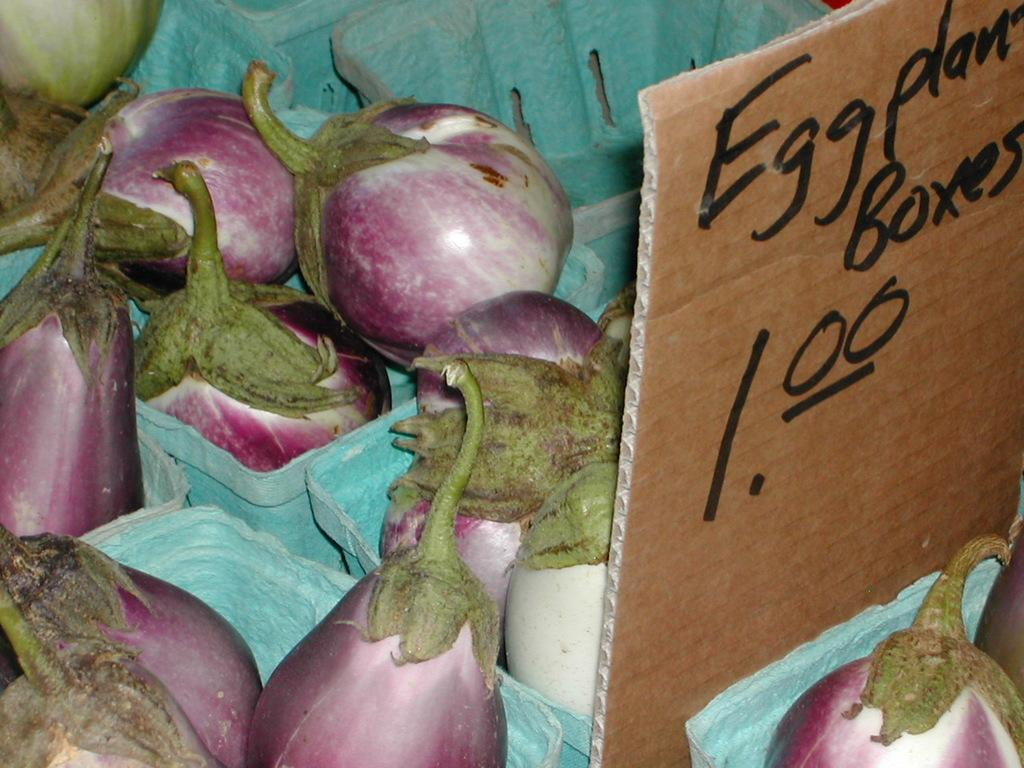What type of vegetable is present in the image? There are eggplants in the image. How are the eggplants arranged in the image? The eggplants are placed in a box. What can be seen on the right side of the image? There is a board on the right side of the image. What is written on the board? There is writing on the board. What type of blade is used to smash the eggplants in the image? There is no blade or smashing of eggplants present in the image. 